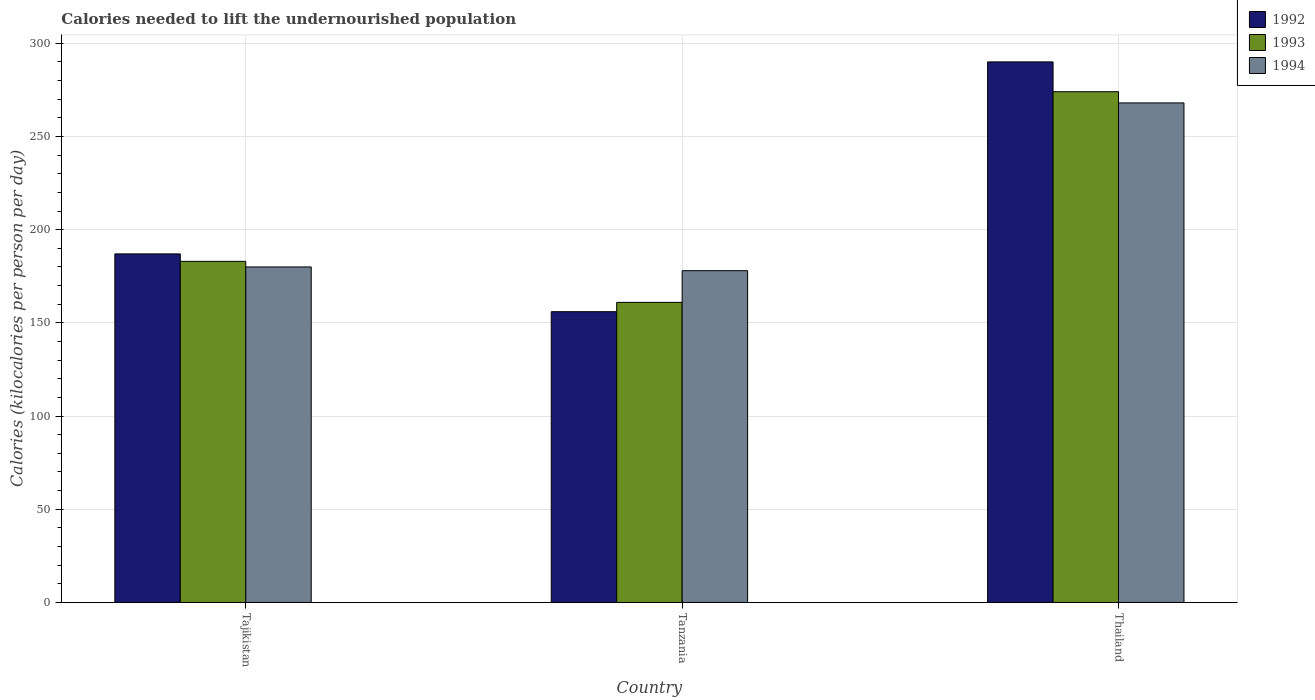How many different coloured bars are there?
Offer a terse response. 3. How many bars are there on the 1st tick from the right?
Your answer should be compact. 3. What is the label of the 2nd group of bars from the left?
Your answer should be compact. Tanzania. What is the total calories needed to lift the undernourished population in 1993 in Thailand?
Keep it short and to the point. 274. Across all countries, what is the maximum total calories needed to lift the undernourished population in 1993?
Provide a short and direct response. 274. Across all countries, what is the minimum total calories needed to lift the undernourished population in 1992?
Provide a succinct answer. 156. In which country was the total calories needed to lift the undernourished population in 1994 maximum?
Provide a succinct answer. Thailand. In which country was the total calories needed to lift the undernourished population in 1992 minimum?
Give a very brief answer. Tanzania. What is the total total calories needed to lift the undernourished population in 1992 in the graph?
Provide a succinct answer. 633. What is the difference between the total calories needed to lift the undernourished population in 1993 in Tajikistan and that in Thailand?
Offer a very short reply. -91. What is the difference between the total calories needed to lift the undernourished population in 1993 in Thailand and the total calories needed to lift the undernourished population in 1994 in Tajikistan?
Offer a terse response. 94. What is the average total calories needed to lift the undernourished population in 1992 per country?
Your answer should be very brief. 211. What is the difference between the total calories needed to lift the undernourished population of/in 1992 and total calories needed to lift the undernourished population of/in 1994 in Tajikistan?
Offer a terse response. 7. In how many countries, is the total calories needed to lift the undernourished population in 1993 greater than 130 kilocalories?
Provide a short and direct response. 3. What is the ratio of the total calories needed to lift the undernourished population in 1994 in Tanzania to that in Thailand?
Provide a short and direct response. 0.66. What is the difference between the highest and the lowest total calories needed to lift the undernourished population in 1993?
Offer a very short reply. 113. Is the sum of the total calories needed to lift the undernourished population in 1992 in Tajikistan and Thailand greater than the maximum total calories needed to lift the undernourished population in 1994 across all countries?
Offer a terse response. Yes. Is it the case that in every country, the sum of the total calories needed to lift the undernourished population in 1992 and total calories needed to lift the undernourished population in 1994 is greater than the total calories needed to lift the undernourished population in 1993?
Your answer should be very brief. Yes. How many bars are there?
Provide a succinct answer. 9. What is the difference between two consecutive major ticks on the Y-axis?
Keep it short and to the point. 50. Are the values on the major ticks of Y-axis written in scientific E-notation?
Make the answer very short. No. Does the graph contain grids?
Provide a succinct answer. Yes. How many legend labels are there?
Ensure brevity in your answer.  3. What is the title of the graph?
Your response must be concise. Calories needed to lift the undernourished population. Does "1970" appear as one of the legend labels in the graph?
Offer a terse response. No. What is the label or title of the X-axis?
Make the answer very short. Country. What is the label or title of the Y-axis?
Make the answer very short. Calories (kilocalories per person per day). What is the Calories (kilocalories per person per day) in 1992 in Tajikistan?
Ensure brevity in your answer.  187. What is the Calories (kilocalories per person per day) of 1993 in Tajikistan?
Your answer should be compact. 183. What is the Calories (kilocalories per person per day) in 1994 in Tajikistan?
Offer a terse response. 180. What is the Calories (kilocalories per person per day) in 1992 in Tanzania?
Your response must be concise. 156. What is the Calories (kilocalories per person per day) in 1993 in Tanzania?
Your answer should be compact. 161. What is the Calories (kilocalories per person per day) in 1994 in Tanzania?
Make the answer very short. 178. What is the Calories (kilocalories per person per day) of 1992 in Thailand?
Make the answer very short. 290. What is the Calories (kilocalories per person per day) of 1993 in Thailand?
Your answer should be compact. 274. What is the Calories (kilocalories per person per day) in 1994 in Thailand?
Your answer should be compact. 268. Across all countries, what is the maximum Calories (kilocalories per person per day) of 1992?
Provide a succinct answer. 290. Across all countries, what is the maximum Calories (kilocalories per person per day) of 1993?
Provide a succinct answer. 274. Across all countries, what is the maximum Calories (kilocalories per person per day) of 1994?
Make the answer very short. 268. Across all countries, what is the minimum Calories (kilocalories per person per day) in 1992?
Make the answer very short. 156. Across all countries, what is the minimum Calories (kilocalories per person per day) in 1993?
Provide a short and direct response. 161. Across all countries, what is the minimum Calories (kilocalories per person per day) in 1994?
Your response must be concise. 178. What is the total Calories (kilocalories per person per day) in 1992 in the graph?
Offer a very short reply. 633. What is the total Calories (kilocalories per person per day) in 1993 in the graph?
Give a very brief answer. 618. What is the total Calories (kilocalories per person per day) of 1994 in the graph?
Your answer should be very brief. 626. What is the difference between the Calories (kilocalories per person per day) in 1992 in Tajikistan and that in Tanzania?
Ensure brevity in your answer.  31. What is the difference between the Calories (kilocalories per person per day) in 1993 in Tajikistan and that in Tanzania?
Offer a very short reply. 22. What is the difference between the Calories (kilocalories per person per day) in 1994 in Tajikistan and that in Tanzania?
Provide a succinct answer. 2. What is the difference between the Calories (kilocalories per person per day) in 1992 in Tajikistan and that in Thailand?
Provide a short and direct response. -103. What is the difference between the Calories (kilocalories per person per day) in 1993 in Tajikistan and that in Thailand?
Provide a succinct answer. -91. What is the difference between the Calories (kilocalories per person per day) in 1994 in Tajikistan and that in Thailand?
Provide a succinct answer. -88. What is the difference between the Calories (kilocalories per person per day) in 1992 in Tanzania and that in Thailand?
Your response must be concise. -134. What is the difference between the Calories (kilocalories per person per day) of 1993 in Tanzania and that in Thailand?
Provide a succinct answer. -113. What is the difference between the Calories (kilocalories per person per day) of 1994 in Tanzania and that in Thailand?
Your answer should be very brief. -90. What is the difference between the Calories (kilocalories per person per day) in 1992 in Tajikistan and the Calories (kilocalories per person per day) in 1993 in Tanzania?
Keep it short and to the point. 26. What is the difference between the Calories (kilocalories per person per day) of 1992 in Tajikistan and the Calories (kilocalories per person per day) of 1993 in Thailand?
Your answer should be very brief. -87. What is the difference between the Calories (kilocalories per person per day) in 1992 in Tajikistan and the Calories (kilocalories per person per day) in 1994 in Thailand?
Give a very brief answer. -81. What is the difference between the Calories (kilocalories per person per day) of 1993 in Tajikistan and the Calories (kilocalories per person per day) of 1994 in Thailand?
Your answer should be very brief. -85. What is the difference between the Calories (kilocalories per person per day) in 1992 in Tanzania and the Calories (kilocalories per person per day) in 1993 in Thailand?
Your answer should be compact. -118. What is the difference between the Calories (kilocalories per person per day) in 1992 in Tanzania and the Calories (kilocalories per person per day) in 1994 in Thailand?
Your response must be concise. -112. What is the difference between the Calories (kilocalories per person per day) of 1993 in Tanzania and the Calories (kilocalories per person per day) of 1994 in Thailand?
Keep it short and to the point. -107. What is the average Calories (kilocalories per person per day) in 1992 per country?
Keep it short and to the point. 211. What is the average Calories (kilocalories per person per day) in 1993 per country?
Offer a very short reply. 206. What is the average Calories (kilocalories per person per day) in 1994 per country?
Offer a terse response. 208.67. What is the difference between the Calories (kilocalories per person per day) of 1992 and Calories (kilocalories per person per day) of 1993 in Tajikistan?
Offer a terse response. 4. What is the difference between the Calories (kilocalories per person per day) in 1992 and Calories (kilocalories per person per day) in 1994 in Tajikistan?
Keep it short and to the point. 7. What is the difference between the Calories (kilocalories per person per day) of 1992 and Calories (kilocalories per person per day) of 1993 in Tanzania?
Your answer should be very brief. -5. What is the difference between the Calories (kilocalories per person per day) in 1992 and Calories (kilocalories per person per day) in 1994 in Tanzania?
Ensure brevity in your answer.  -22. What is the difference between the Calories (kilocalories per person per day) in 1993 and Calories (kilocalories per person per day) in 1994 in Tanzania?
Provide a succinct answer. -17. What is the difference between the Calories (kilocalories per person per day) in 1992 and Calories (kilocalories per person per day) in 1994 in Thailand?
Your response must be concise. 22. What is the difference between the Calories (kilocalories per person per day) in 1993 and Calories (kilocalories per person per day) in 1994 in Thailand?
Make the answer very short. 6. What is the ratio of the Calories (kilocalories per person per day) in 1992 in Tajikistan to that in Tanzania?
Keep it short and to the point. 1.2. What is the ratio of the Calories (kilocalories per person per day) in 1993 in Tajikistan to that in Tanzania?
Your answer should be compact. 1.14. What is the ratio of the Calories (kilocalories per person per day) of 1994 in Tajikistan to that in Tanzania?
Offer a very short reply. 1.01. What is the ratio of the Calories (kilocalories per person per day) in 1992 in Tajikistan to that in Thailand?
Make the answer very short. 0.64. What is the ratio of the Calories (kilocalories per person per day) of 1993 in Tajikistan to that in Thailand?
Provide a succinct answer. 0.67. What is the ratio of the Calories (kilocalories per person per day) in 1994 in Tajikistan to that in Thailand?
Offer a very short reply. 0.67. What is the ratio of the Calories (kilocalories per person per day) in 1992 in Tanzania to that in Thailand?
Make the answer very short. 0.54. What is the ratio of the Calories (kilocalories per person per day) in 1993 in Tanzania to that in Thailand?
Your answer should be very brief. 0.59. What is the ratio of the Calories (kilocalories per person per day) in 1994 in Tanzania to that in Thailand?
Keep it short and to the point. 0.66. What is the difference between the highest and the second highest Calories (kilocalories per person per day) of 1992?
Your answer should be compact. 103. What is the difference between the highest and the second highest Calories (kilocalories per person per day) in 1993?
Keep it short and to the point. 91. What is the difference between the highest and the lowest Calories (kilocalories per person per day) in 1992?
Offer a very short reply. 134. What is the difference between the highest and the lowest Calories (kilocalories per person per day) in 1993?
Provide a short and direct response. 113. What is the difference between the highest and the lowest Calories (kilocalories per person per day) in 1994?
Offer a terse response. 90. 